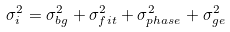<formula> <loc_0><loc_0><loc_500><loc_500>\sigma _ { i } ^ { 2 } = \sigma _ { b g } ^ { 2 } + \sigma _ { f i t } ^ { 2 } + \sigma _ { p h a s e } ^ { 2 } + \sigma _ { g e } ^ { 2 }</formula> 